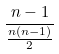Convert formula to latex. <formula><loc_0><loc_0><loc_500><loc_500>\frac { n - 1 } { \frac { n ( n - 1 ) } { 2 } }</formula> 